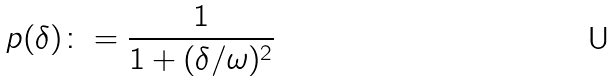<formula> <loc_0><loc_0><loc_500><loc_500>p ( \delta ) \colon = \frac { 1 } { 1 + ( \delta / \omega ) ^ { 2 } }</formula> 